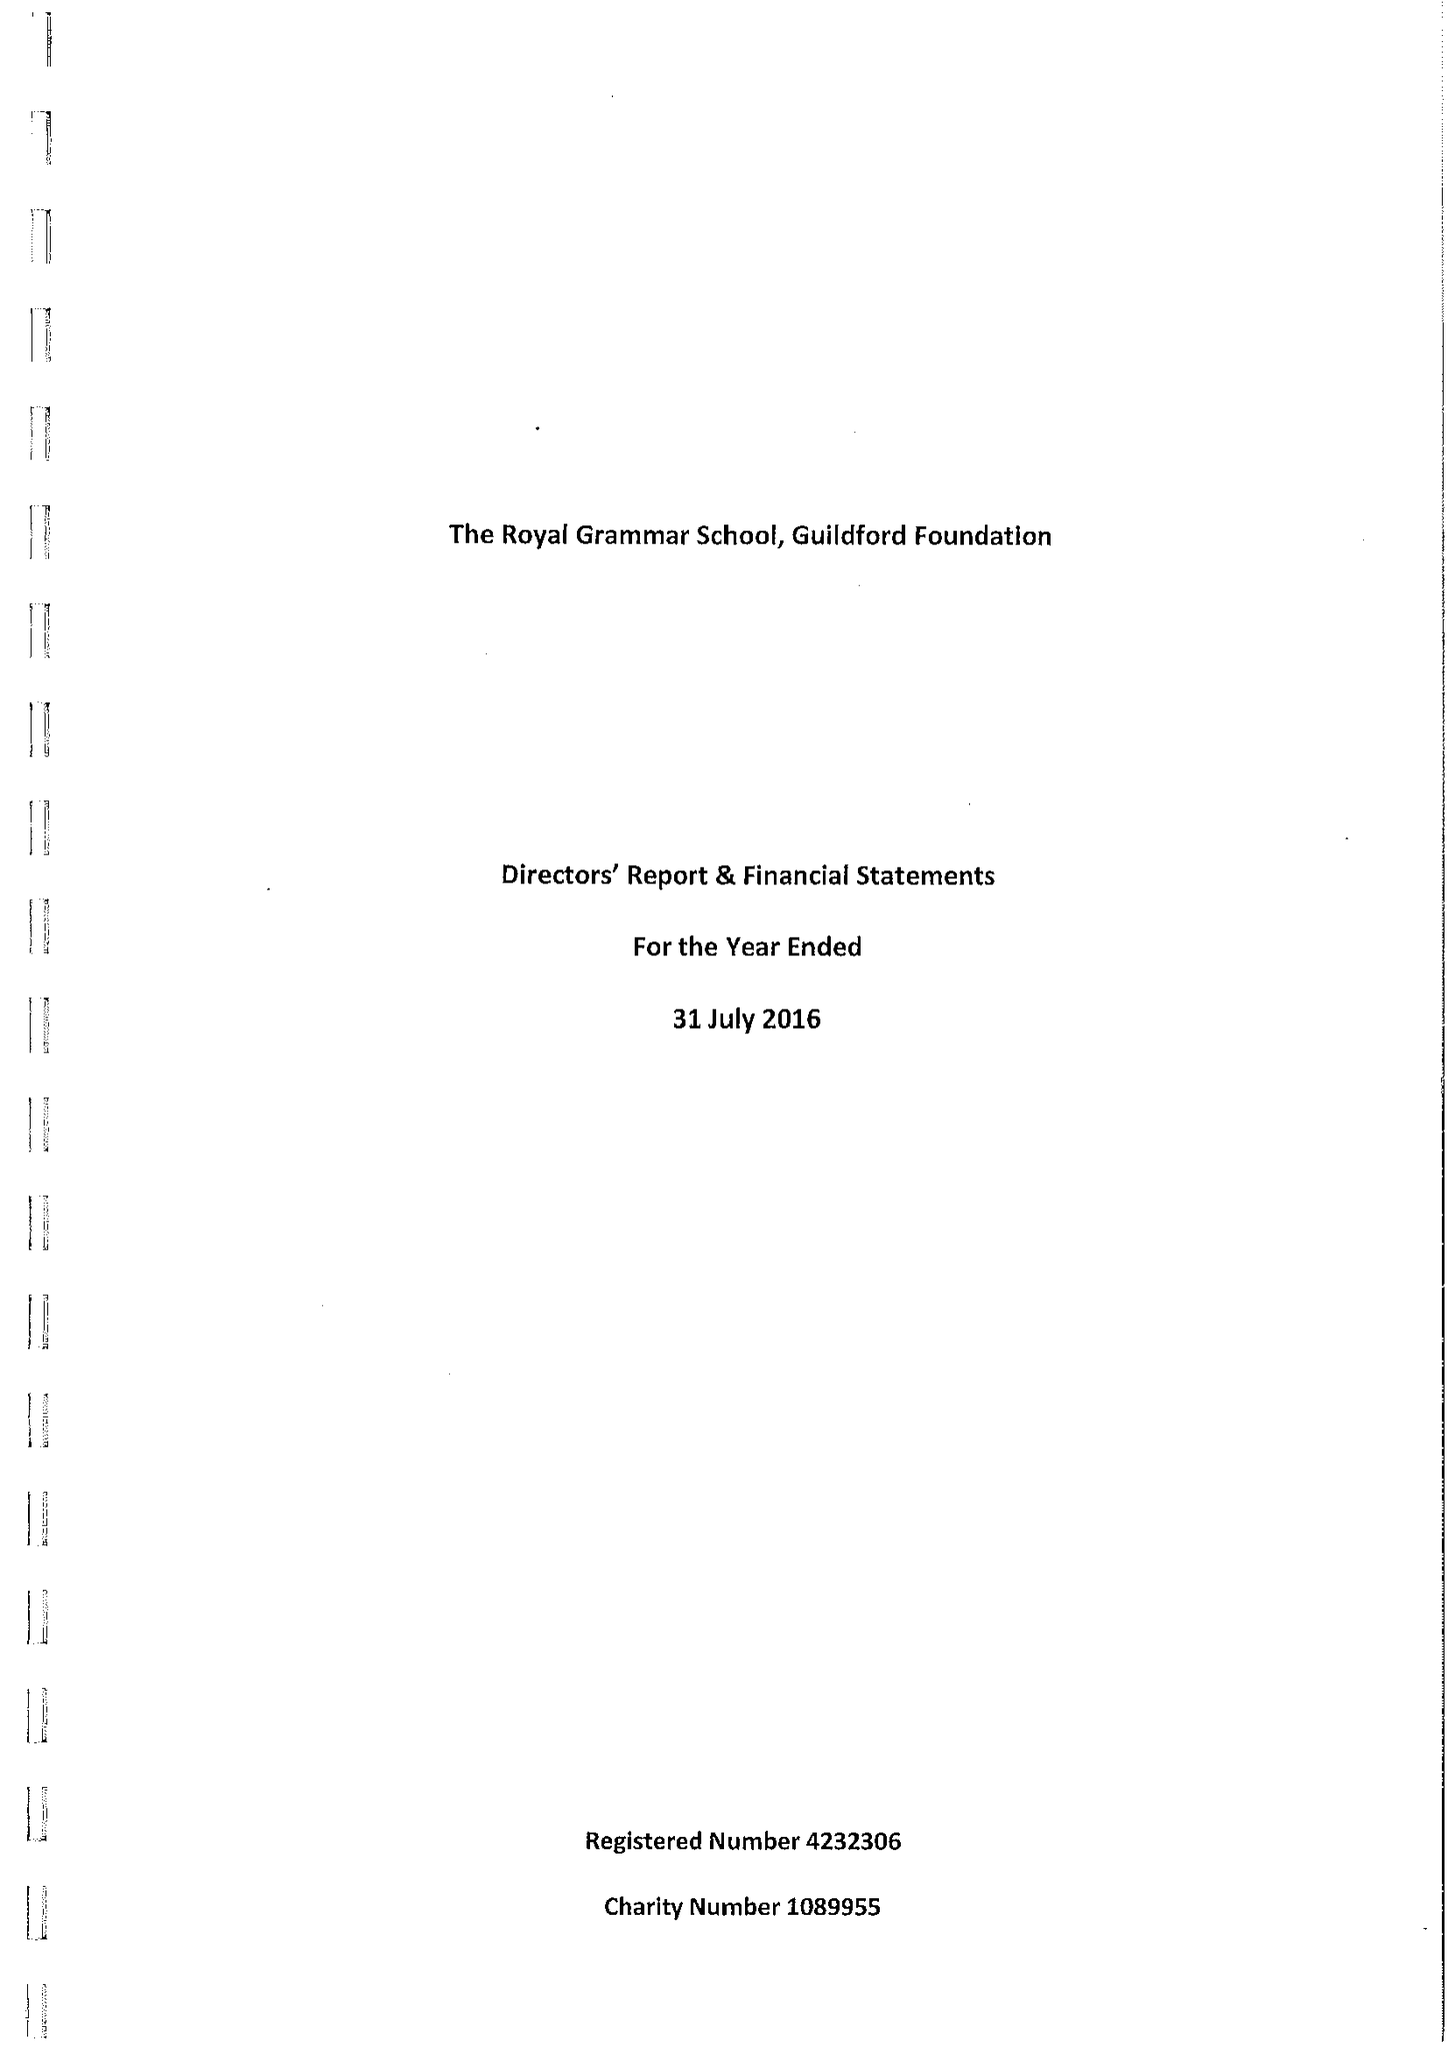What is the value for the charity_name?
Answer the question using a single word or phrase. The Royal Grammar School, Guildford Foundation 